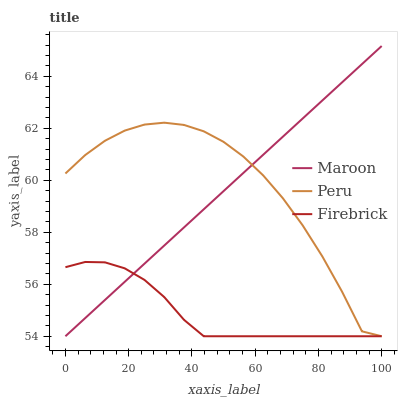Does Firebrick have the minimum area under the curve?
Answer yes or no. Yes. Does Peru have the maximum area under the curve?
Answer yes or no. Yes. Does Maroon have the minimum area under the curve?
Answer yes or no. No. Does Maroon have the maximum area under the curve?
Answer yes or no. No. Is Maroon the smoothest?
Answer yes or no. Yes. Is Peru the roughest?
Answer yes or no. Yes. Is Peru the smoothest?
Answer yes or no. No. Is Maroon the roughest?
Answer yes or no. No. Does Firebrick have the lowest value?
Answer yes or no. Yes. Does Maroon have the highest value?
Answer yes or no. Yes. Does Peru have the highest value?
Answer yes or no. No. Does Peru intersect Maroon?
Answer yes or no. Yes. Is Peru less than Maroon?
Answer yes or no. No. Is Peru greater than Maroon?
Answer yes or no. No. 